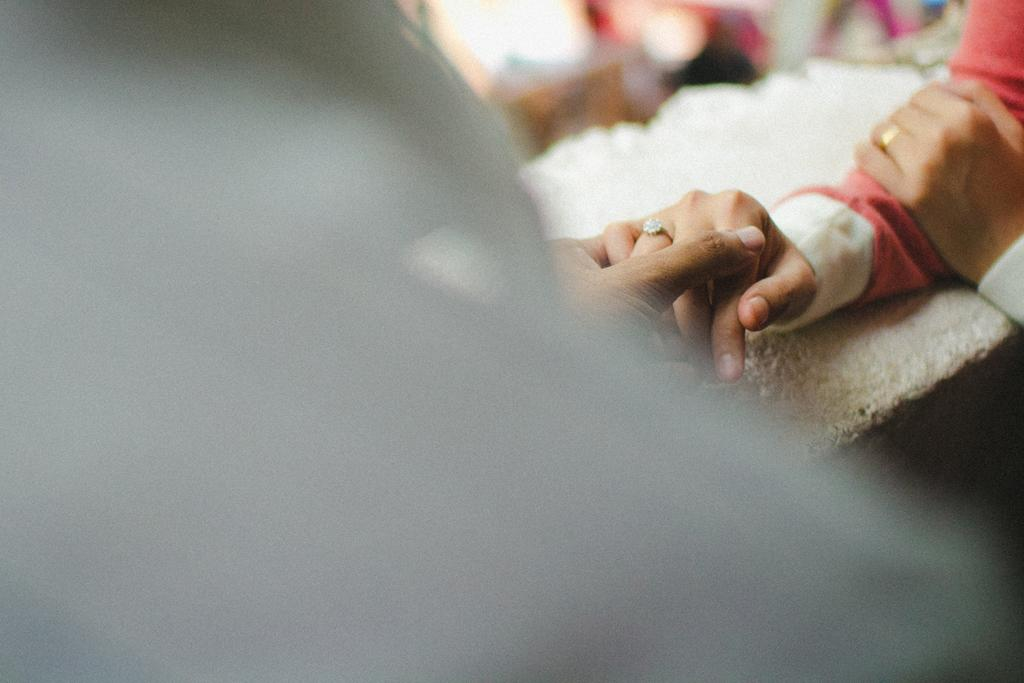What are the people in the image doing with their hands? The people in the image are holding their hands on the right side. Can you describe the background and left side of the image? The background and left side of the image are blurry. What type of screw can be seen in the image? There is no screw present in the image. What kind of sand is visible in the image? There is no sand visible in the image. 